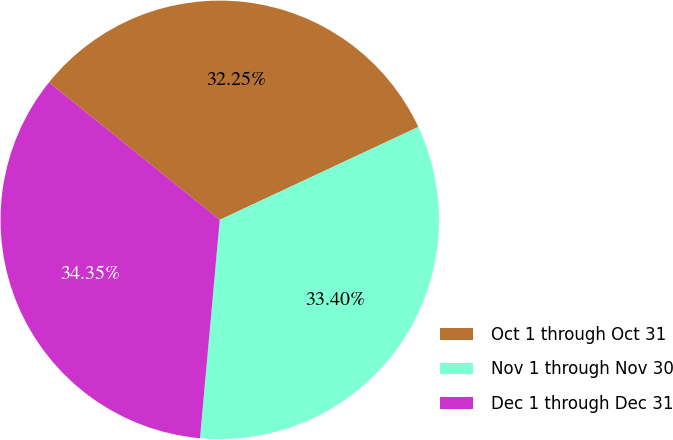Convert chart. <chart><loc_0><loc_0><loc_500><loc_500><pie_chart><fcel>Oct 1 through Oct 31<fcel>Nov 1 through Nov 30<fcel>Dec 1 through Dec 31<nl><fcel>32.25%<fcel>33.4%<fcel>34.35%<nl></chart> 